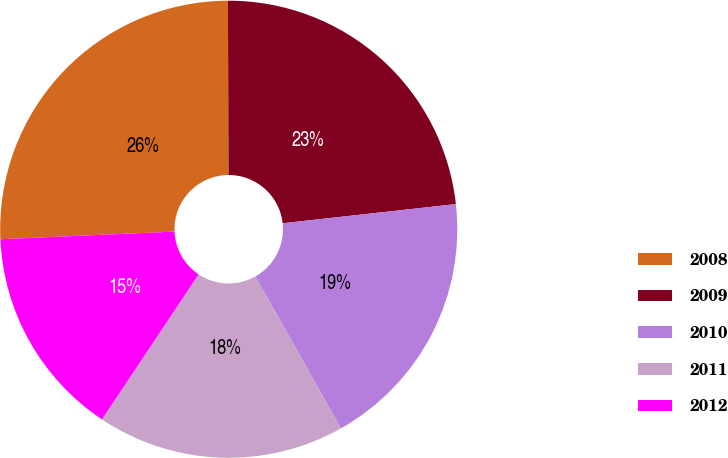Convert chart to OTSL. <chart><loc_0><loc_0><loc_500><loc_500><pie_chart><fcel>2008<fcel>2009<fcel>2010<fcel>2011<fcel>2012<nl><fcel>25.64%<fcel>23.3%<fcel>18.59%<fcel>17.52%<fcel>14.95%<nl></chart> 